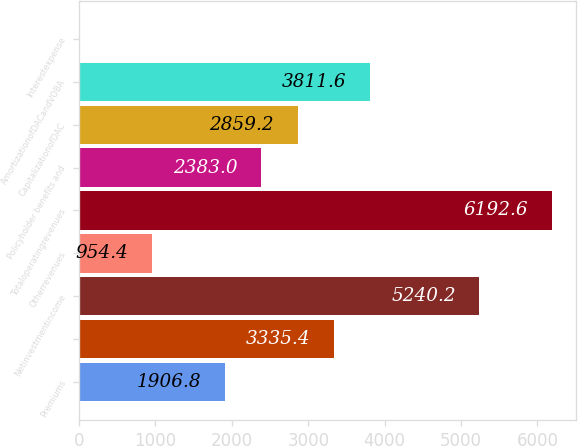Convert chart to OTSL. <chart><loc_0><loc_0><loc_500><loc_500><bar_chart><fcel>Premiums<fcel>Unnamed: 1<fcel>Netinvestmentincome<fcel>Otherrevenues<fcel>Totaloperatingrevenues<fcel>Policyholder benefits and<fcel>CapitalizationofDAC<fcel>AmortizationofDACandVOBA<fcel>Interestexpense<nl><fcel>1906.8<fcel>3335.4<fcel>5240.2<fcel>954.4<fcel>6192.6<fcel>2383<fcel>2859.2<fcel>3811.6<fcel>2<nl></chart> 